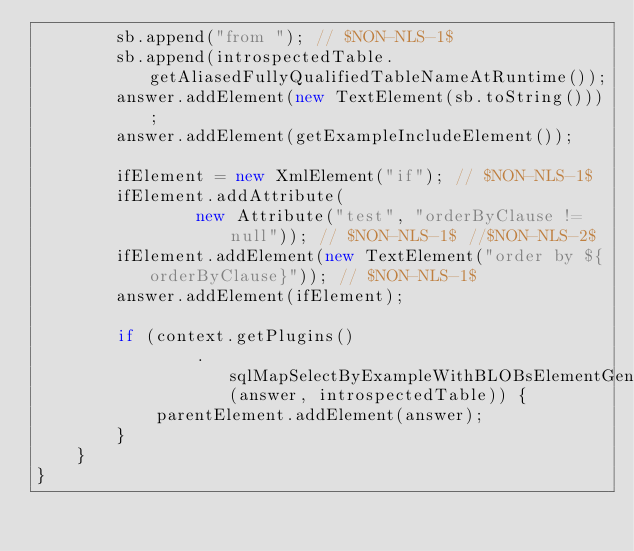Convert code to text. <code><loc_0><loc_0><loc_500><loc_500><_Java_>        sb.append("from "); // $NON-NLS-1$
        sb.append(introspectedTable.getAliasedFullyQualifiedTableNameAtRuntime());
        answer.addElement(new TextElement(sb.toString()));
        answer.addElement(getExampleIncludeElement());

        ifElement = new XmlElement("if"); // $NON-NLS-1$
        ifElement.addAttribute(
                new Attribute("test", "orderByClause != null")); // $NON-NLS-1$ //$NON-NLS-2$
        ifElement.addElement(new TextElement("order by ${orderByClause}")); // $NON-NLS-1$
        answer.addElement(ifElement);

        if (context.getPlugins()
                .sqlMapSelectByExampleWithBLOBsElementGenerated(answer, introspectedTable)) {
            parentElement.addElement(answer);
        }
    }
}
</code> 